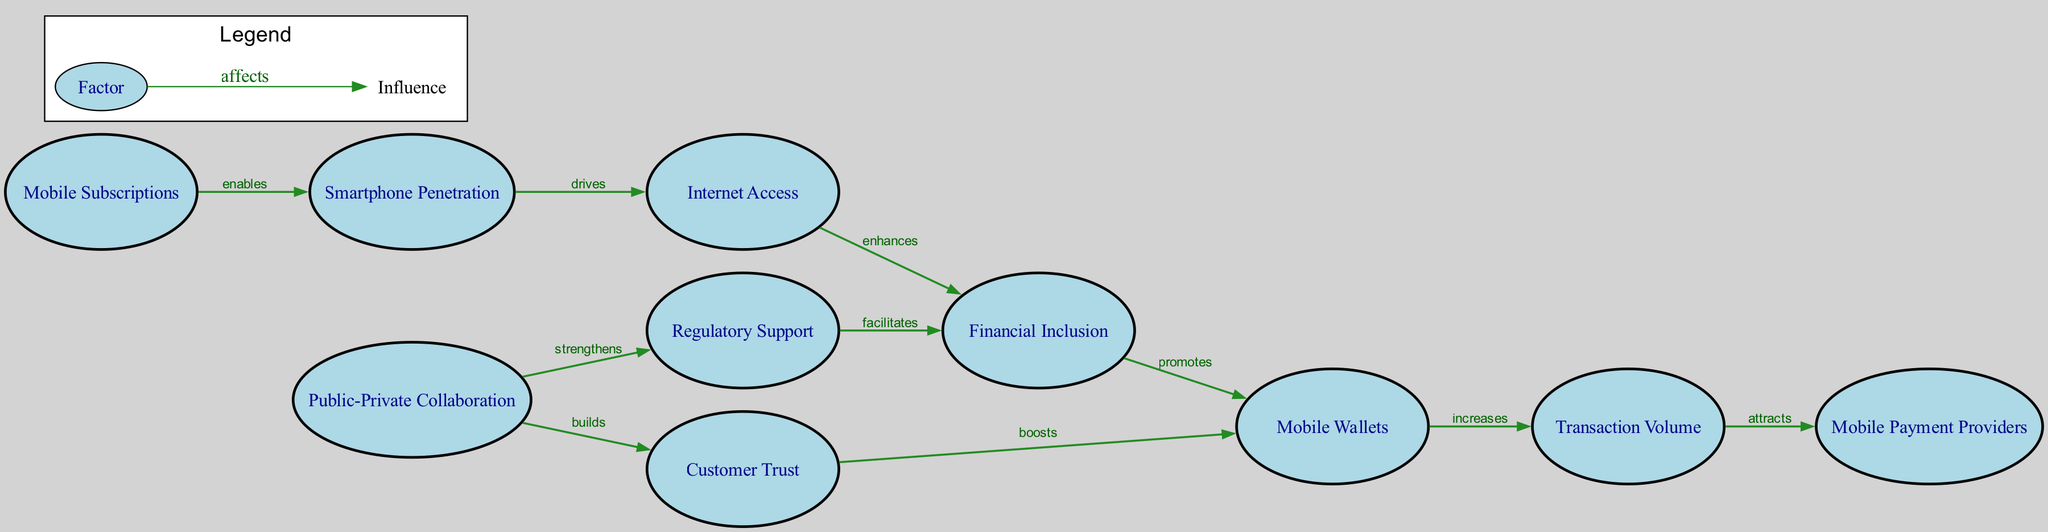What is the total number of nodes in the diagram? The diagram lists 10 distinct entities or concepts represented as nodes: Mobile Subscriptions, Smartphone Penetration, Internet Access, Financial Inclusion, Mobile Wallets, Regulatory Support, Customer Trust, Transaction Volume, Mobile Payment Providers, and Public-Private Collaboration. Thus, when counting these entities, the total is 10.
Answer: 10 What two nodes are directly connected by the "increases" edge? Observing the edges, the node "Mobile Wallets" is connected to "Transaction Volume" via an edge labeled "increases". This indicates that an increase in mobile wallets leads to an increase in transaction volume.
Answer: Mobile Wallets, Transaction Volume Which node facilitates financial inclusion? The diagram shows that "Regulatory Support" has a directed edge labeled "facilitates" leading to "Financial Inclusion". This indicates that regulatory support plays a crucial role in enhancing financial inclusion.
Answer: Regulatory Support What is the relationship between internet access and financial inclusion? Looking at the edge labels, it states that "Internet Access" enhances "Financial Inclusion", meaning that greater access to the internet leads to improved financial inclusion among users.
Answer: enhances Which two factors does public-private collaboration strengthen? From the diagram, public-private collaboration has edges leading to both "Regulatory Support" and "Customer Trust", indicating that this collaboration strengthens these two aspects essential for mobile payment adoption.
Answer: Regulatory Support, Customer Trust What does customer trust boost? The edge from "Customer Trust" to "Mobile Wallets" labeled "boosts" indicates that when customer trust increases, it positively affects the adoption and usage of mobile wallets.
Answer: Mobile Wallets How does smartphone penetration relate to internet access? The edge labeled "drives" between "Smartphone Penetration" and "Internet Access" signifies that an increase in smartphone penetration leads to increased internet access, establishing a direct relationship between these two factors.
Answer: drives What influences mobile payment providers? "Transaction Volume" has a directed edge to "Mobile Payment Providers" with the label "attracts", indicating that an increase in transaction volume attracts more mobile payment providers to the market.
Answer: attracts 